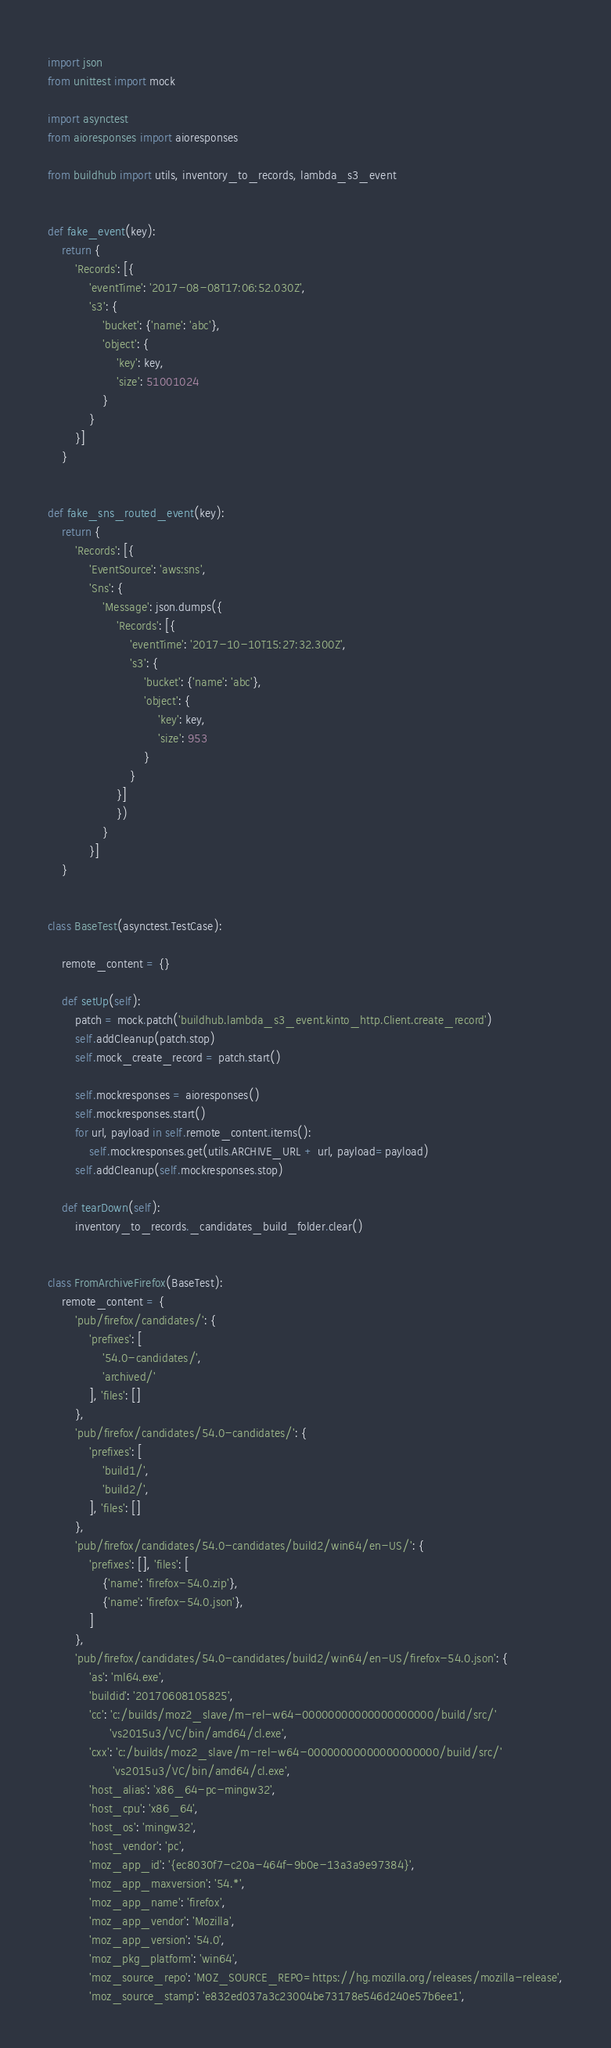<code> <loc_0><loc_0><loc_500><loc_500><_Python_>import json
from unittest import mock

import asynctest
from aioresponses import aioresponses

from buildhub import utils, inventory_to_records, lambda_s3_event


def fake_event(key):
    return {
        'Records': [{
            'eventTime': '2017-08-08T17:06:52.030Z',
            's3': {
                'bucket': {'name': 'abc'},
                'object': {
                    'key': key,
                    'size': 51001024
                }
            }
        }]
    }


def fake_sns_routed_event(key):
    return {
        'Records': [{
            'EventSource': 'aws:sns',
            'Sns': {
                'Message': json.dumps({
                    'Records': [{
                        'eventTime': '2017-10-10T15:27:32.300Z',
                        's3': {
                            'bucket': {'name': 'abc'},
                            'object': {
                                'key': key,
                                'size': 953
                            }
                        }
                    }]
                    })
                }
            }]
    }


class BaseTest(asynctest.TestCase):

    remote_content = {}

    def setUp(self):
        patch = mock.patch('buildhub.lambda_s3_event.kinto_http.Client.create_record')
        self.addCleanup(patch.stop)
        self.mock_create_record = patch.start()

        self.mockresponses = aioresponses()
        self.mockresponses.start()
        for url, payload in self.remote_content.items():
            self.mockresponses.get(utils.ARCHIVE_URL + url, payload=payload)
        self.addCleanup(self.mockresponses.stop)

    def tearDown(self):
        inventory_to_records._candidates_build_folder.clear()


class FromArchiveFirefox(BaseTest):
    remote_content = {
        'pub/firefox/candidates/': {
            'prefixes': [
                '54.0-candidates/',
                'archived/'
            ], 'files': []
        },
        'pub/firefox/candidates/54.0-candidates/': {
            'prefixes': [
                'build1/',
                'build2/',
            ], 'files': []
        },
        'pub/firefox/candidates/54.0-candidates/build2/win64/en-US/': {
            'prefixes': [], 'files': [
                {'name': 'firefox-54.0.zip'},
                {'name': 'firefox-54.0.json'},
            ]
        },
        'pub/firefox/candidates/54.0-candidates/build2/win64/en-US/firefox-54.0.json': {
            'as': 'ml64.exe',
            'buildid': '20170608105825',
            'cc': 'c:/builds/moz2_slave/m-rel-w64-00000000000000000000/build/src/'
                  'vs2015u3/VC/bin/amd64/cl.exe',
            'cxx': 'c:/builds/moz2_slave/m-rel-w64-00000000000000000000/build/src/'
                   'vs2015u3/VC/bin/amd64/cl.exe',
            'host_alias': 'x86_64-pc-mingw32',
            'host_cpu': 'x86_64',
            'host_os': 'mingw32',
            'host_vendor': 'pc',
            'moz_app_id': '{ec8030f7-c20a-464f-9b0e-13a3a9e97384}',
            'moz_app_maxversion': '54.*',
            'moz_app_name': 'firefox',
            'moz_app_vendor': 'Mozilla',
            'moz_app_version': '54.0',
            'moz_pkg_platform': 'win64',
            'moz_source_repo': 'MOZ_SOURCE_REPO=https://hg.mozilla.org/releases/mozilla-release',
            'moz_source_stamp': 'e832ed037a3c23004be73178e546d240e57b6ee1',</code> 